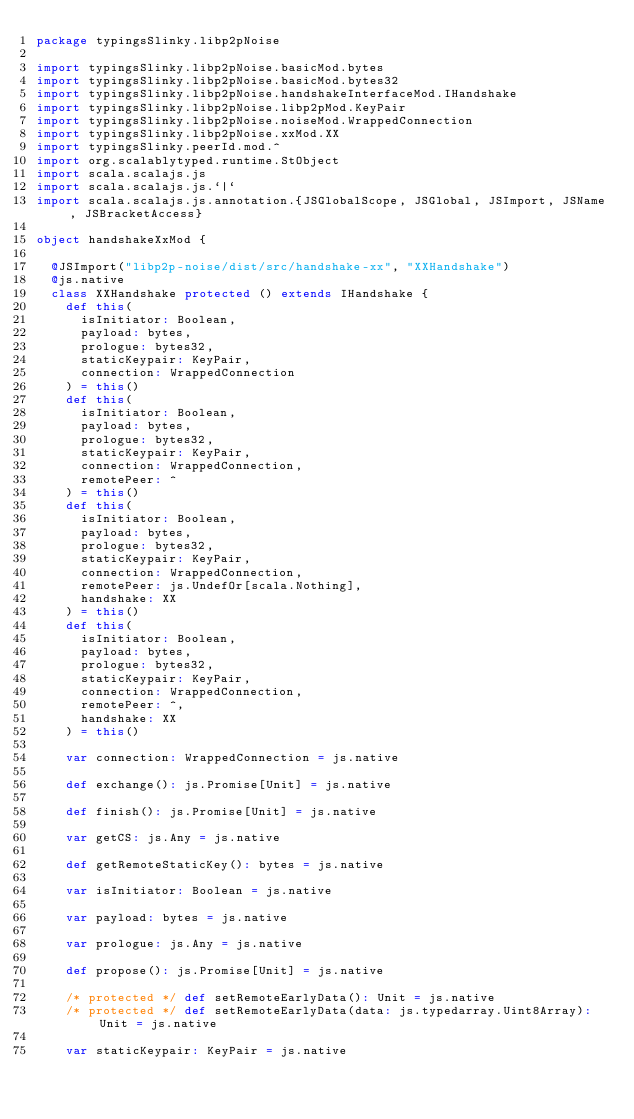<code> <loc_0><loc_0><loc_500><loc_500><_Scala_>package typingsSlinky.libp2pNoise

import typingsSlinky.libp2pNoise.basicMod.bytes
import typingsSlinky.libp2pNoise.basicMod.bytes32
import typingsSlinky.libp2pNoise.handshakeInterfaceMod.IHandshake
import typingsSlinky.libp2pNoise.libp2pMod.KeyPair
import typingsSlinky.libp2pNoise.noiseMod.WrappedConnection
import typingsSlinky.libp2pNoise.xxMod.XX
import typingsSlinky.peerId.mod.^
import org.scalablytyped.runtime.StObject
import scala.scalajs.js
import scala.scalajs.js.`|`
import scala.scalajs.js.annotation.{JSGlobalScope, JSGlobal, JSImport, JSName, JSBracketAccess}

object handshakeXxMod {
  
  @JSImport("libp2p-noise/dist/src/handshake-xx", "XXHandshake")
  @js.native
  class XXHandshake protected () extends IHandshake {
    def this(
      isInitiator: Boolean,
      payload: bytes,
      prologue: bytes32,
      staticKeypair: KeyPair,
      connection: WrappedConnection
    ) = this()
    def this(
      isInitiator: Boolean,
      payload: bytes,
      prologue: bytes32,
      staticKeypair: KeyPair,
      connection: WrappedConnection,
      remotePeer: ^
    ) = this()
    def this(
      isInitiator: Boolean,
      payload: bytes,
      prologue: bytes32,
      staticKeypair: KeyPair,
      connection: WrappedConnection,
      remotePeer: js.UndefOr[scala.Nothing],
      handshake: XX
    ) = this()
    def this(
      isInitiator: Boolean,
      payload: bytes,
      prologue: bytes32,
      staticKeypair: KeyPair,
      connection: WrappedConnection,
      remotePeer: ^,
      handshake: XX
    ) = this()
    
    var connection: WrappedConnection = js.native
    
    def exchange(): js.Promise[Unit] = js.native
    
    def finish(): js.Promise[Unit] = js.native
    
    var getCS: js.Any = js.native
    
    def getRemoteStaticKey(): bytes = js.native
    
    var isInitiator: Boolean = js.native
    
    var payload: bytes = js.native
    
    var prologue: js.Any = js.native
    
    def propose(): js.Promise[Unit] = js.native
    
    /* protected */ def setRemoteEarlyData(): Unit = js.native
    /* protected */ def setRemoteEarlyData(data: js.typedarray.Uint8Array): Unit = js.native
    
    var staticKeypair: KeyPair = js.native
    </code> 